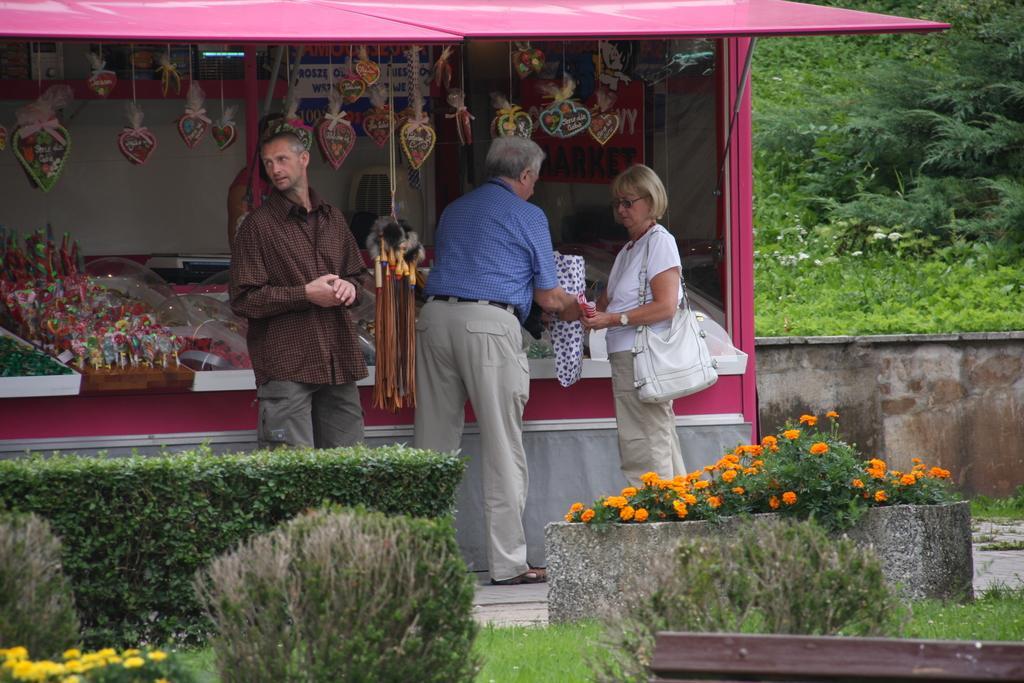Describe this image in one or two sentences. This image consists of three persons. On the right, the woman is wearing a handbag. At the bottom, there are plants along with flowers. In the background, we can see a shop. On the right, there are trees. 